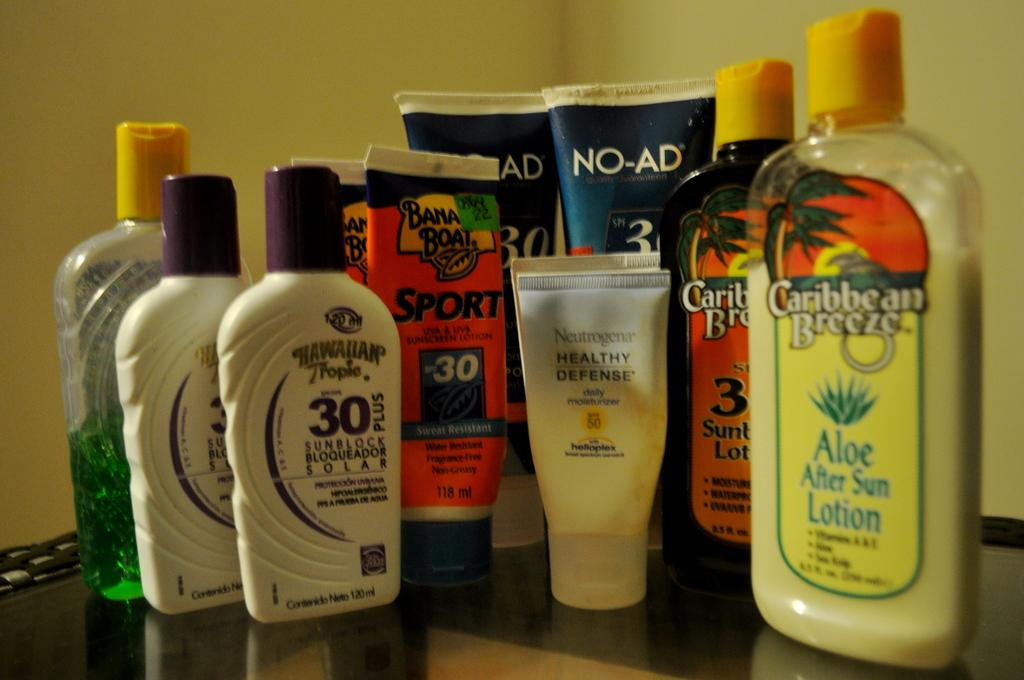<image>
Relay a brief, clear account of the picture shown. Several bottles of different lotions of varying brands like caribbean breeze. 